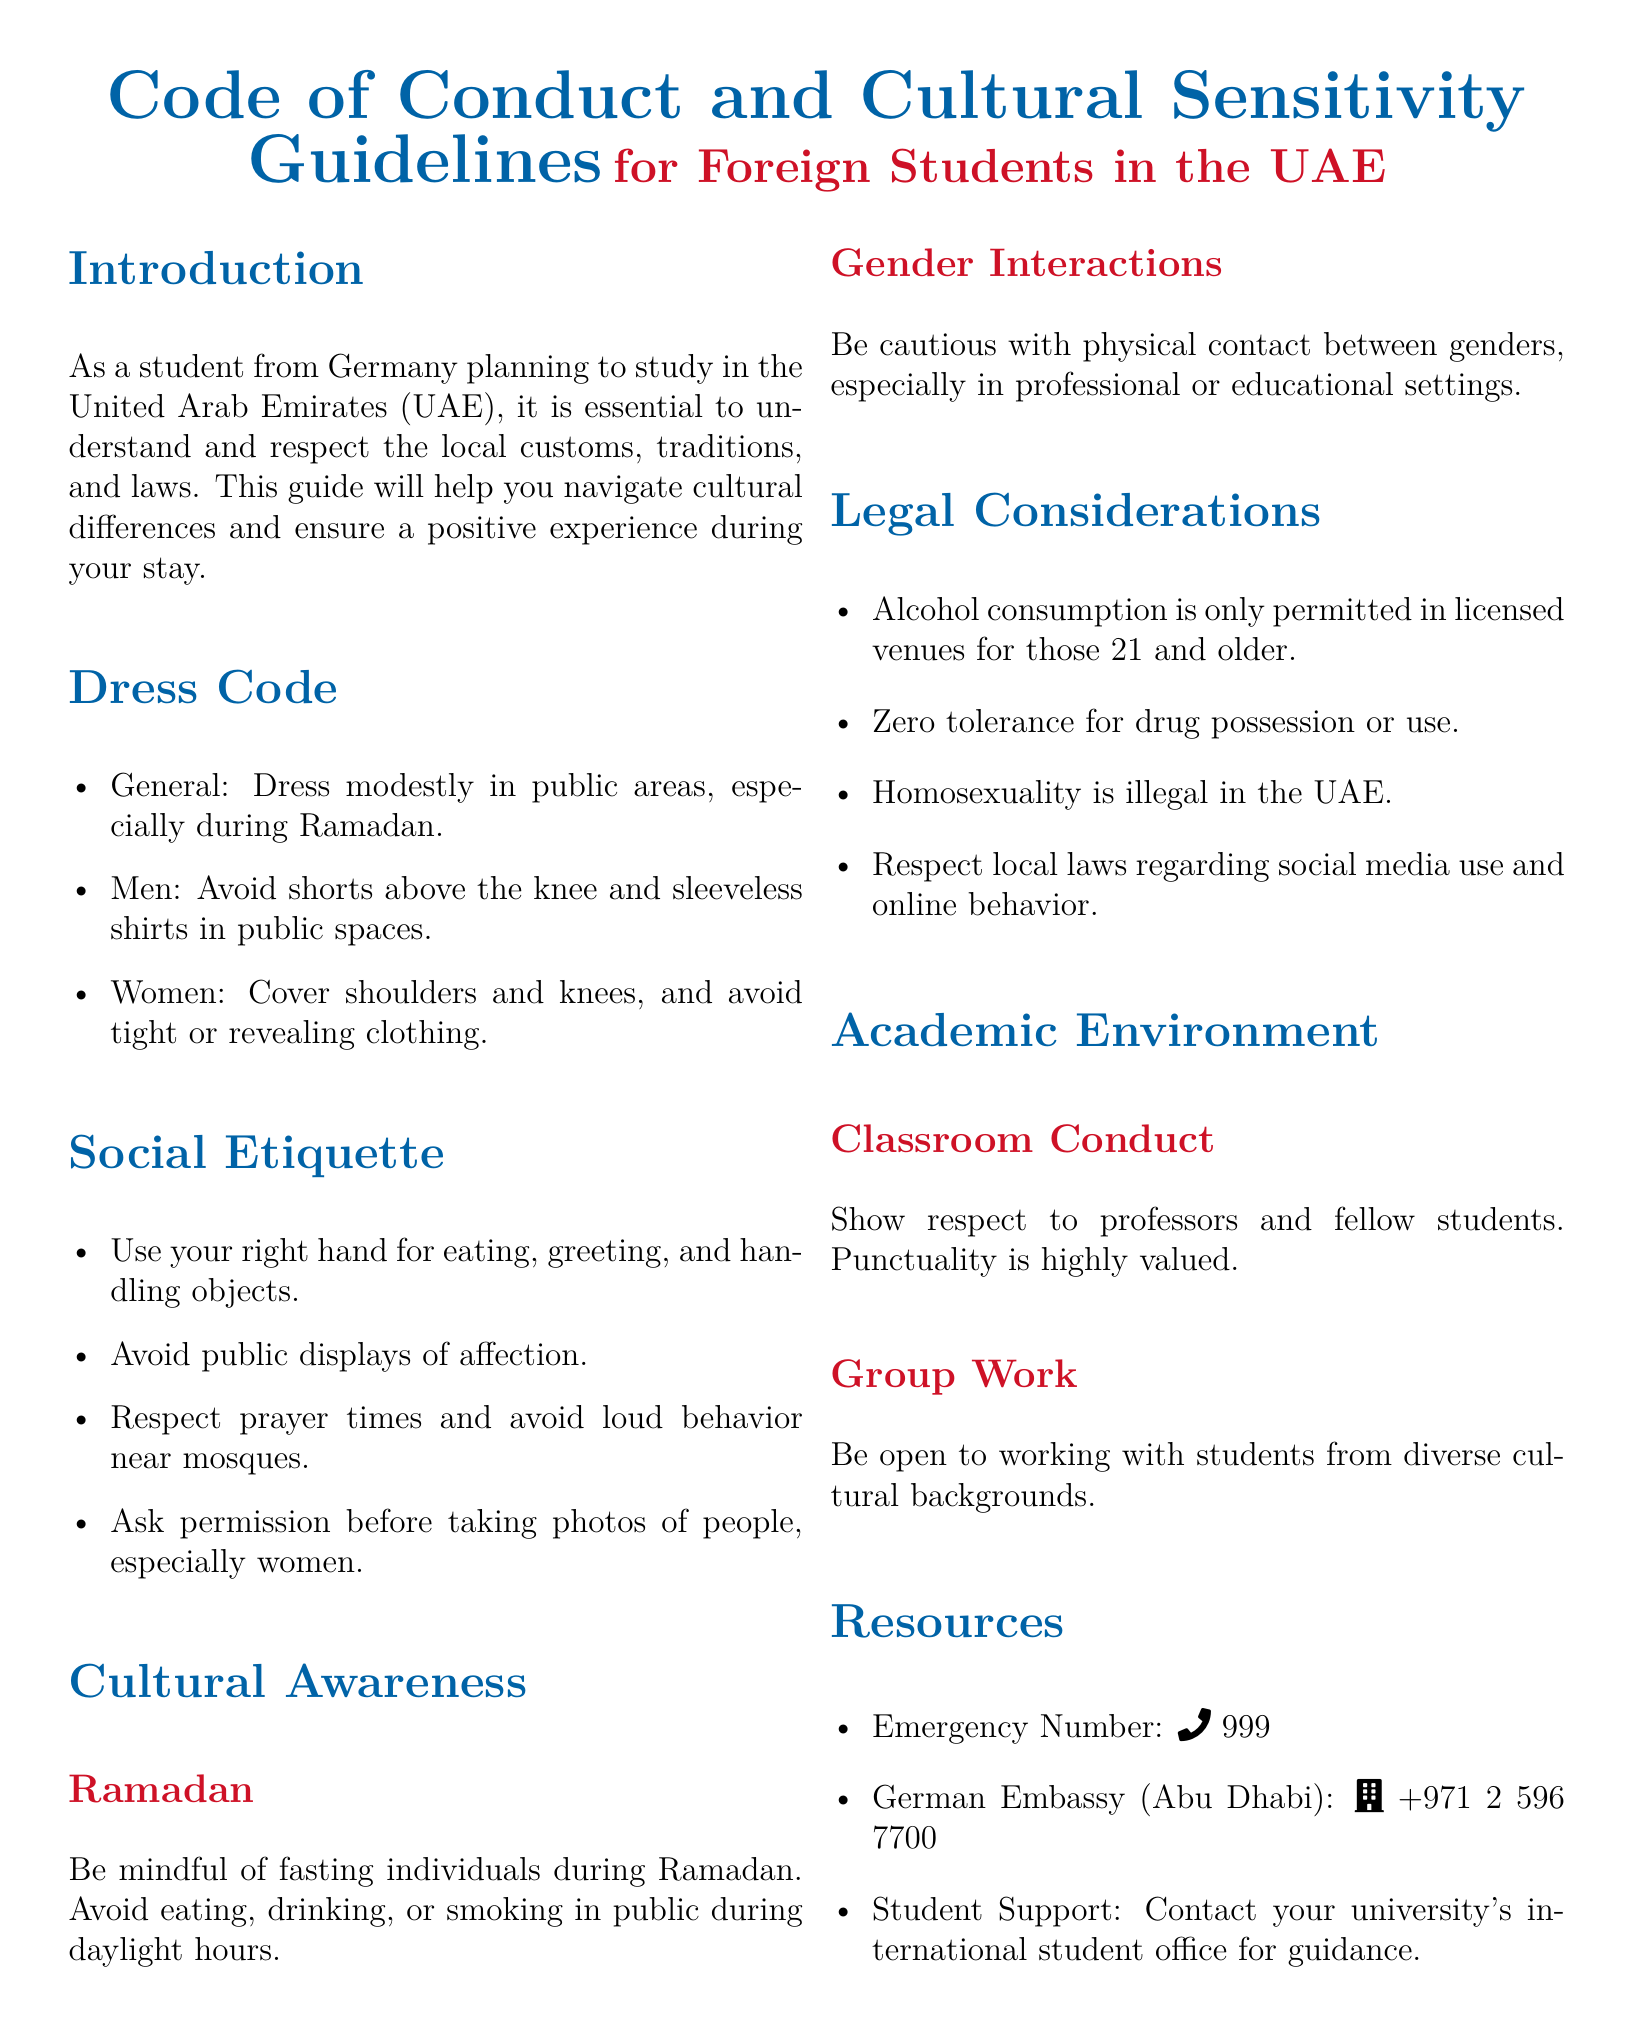what is the dress code for women in public areas? The document specifies that women should cover shoulders and knees, and avoid tight or revealing clothing in public areas.
Answer: cover shoulders and knees how should you eat and greet in the UAE? The guidelines state that you should use your right hand for eating and greeting in the UAE.
Answer: right hand what is the emergency number in the UAE? The document provides the emergency number as a critical resource for students in need.
Answer: 999 which cultural practice should be observed during Ramadan? The document indicates that it is essential to be mindful of fasting individuals during Ramadan by avoiding eating, drinking, or smoking in public during daylight hours.
Answer: avoid eating, drinking, or smoking what is the legal drinking age in the UAE? The guidelines mention that alcohol consumption is permitted only for those who are 21 and older in licensed venues.
Answer: 21 how should students behave in group work? The document advises students to be open to working with students from diverse cultural backgrounds during group work.
Answer: open to diversity what actions are considered inappropriate in public according to the guidelines? The document states that public displays of affection should be avoided as part of social etiquette in the UAE.
Answer: public displays of affection what is the policy on drug use in the UAE? The guidelines highlight that there is zero tolerance for drug possession or use in the UAE.
Answer: zero tolerance when are prayer times especially respected? The document notes that loud behavior should be avoided near mosques during prayer times to show respect.
Answer: near mosques 